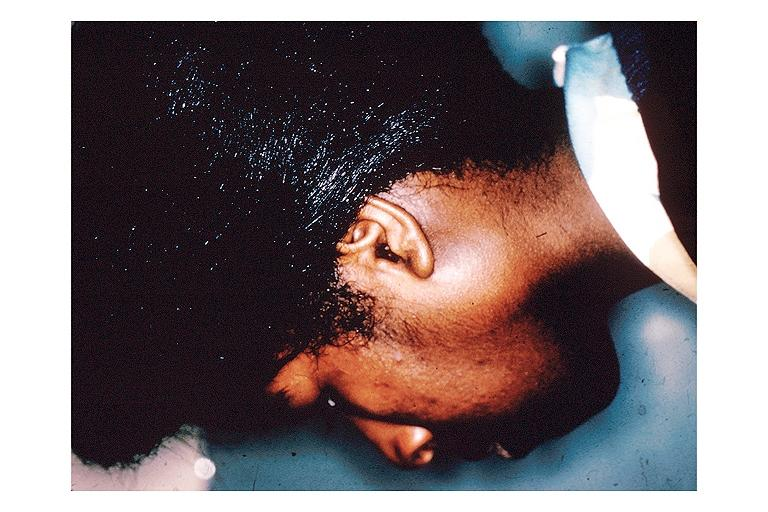where is this?
Answer the question using a single word or phrase. Oral 